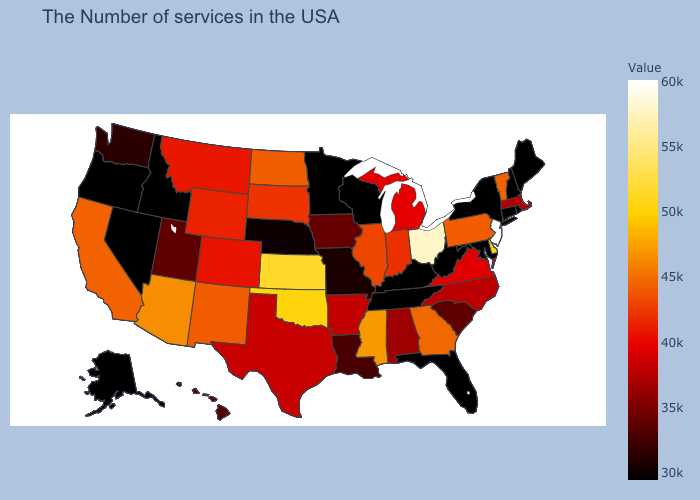Is the legend a continuous bar?
Give a very brief answer. Yes. Which states have the lowest value in the South?
Write a very short answer. Maryland, West Virginia, Florida, Kentucky, Tennessee. Which states have the highest value in the USA?
Quick response, please. New Jersey. Does Kentucky have a higher value than Massachusetts?
Write a very short answer. No. Does North Carolina have a lower value than Washington?
Short answer required. No. Which states have the lowest value in the USA?
Quick response, please. Maine, Rhode Island, New Hampshire, Connecticut, New York, Maryland, West Virginia, Florida, Kentucky, Tennessee, Wisconsin, Minnesota, Idaho, Nevada, Oregon, Alaska. Does New Hampshire have the lowest value in the USA?
Keep it brief. Yes. Among the states that border North Carolina , which have the highest value?
Answer briefly. Georgia. Among the states that border Montana , which have the lowest value?
Quick response, please. Idaho. 